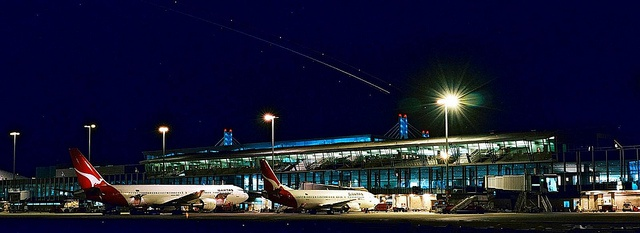Describe the objects in this image and their specific colors. I can see airplane in navy, black, white, maroon, and tan tones and airplane in navy, black, ivory, beige, and tan tones in this image. 